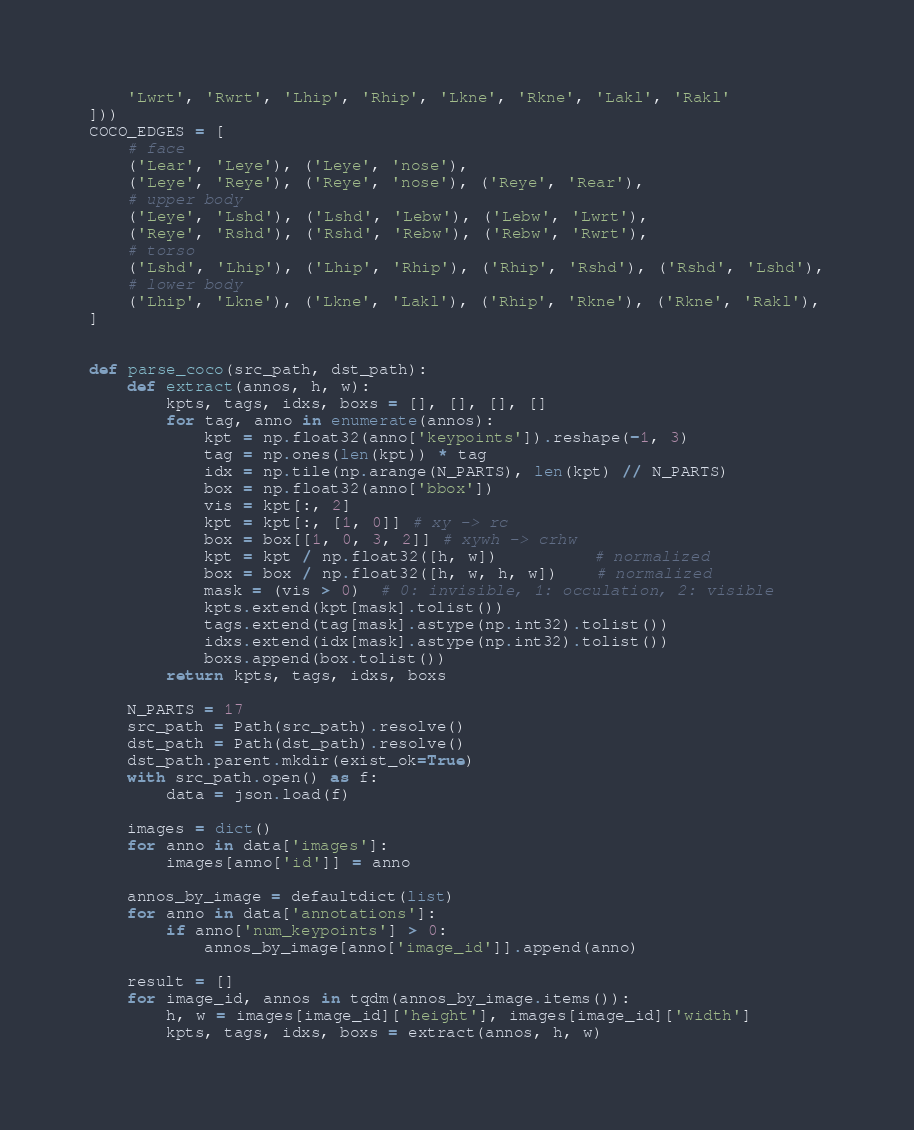Convert code to text. <code><loc_0><loc_0><loc_500><loc_500><_Python_>    'Lwrt', 'Rwrt', 'Lhip', 'Rhip', 'Lkne', 'Rkne', 'Lakl', 'Rakl'
]))
COCO_EDGES = [
    # face
    ('Lear', 'Leye'), ('Leye', 'nose'),
    ('Leye', 'Reye'), ('Reye', 'nose'), ('Reye', 'Rear'),
    # upper body
    ('Leye', 'Lshd'), ('Lshd', 'Lebw'), ('Lebw', 'Lwrt'),
    ('Reye', 'Rshd'), ('Rshd', 'Rebw'), ('Rebw', 'Rwrt'),
    # torso
    ('Lshd', 'Lhip'), ('Lhip', 'Rhip'), ('Rhip', 'Rshd'), ('Rshd', 'Lshd'),
    # lower body
    ('Lhip', 'Lkne'), ('Lkne', 'Lakl'), ('Rhip', 'Rkne'), ('Rkne', 'Rakl'),
]


def parse_coco(src_path, dst_path):
    def extract(annos, h, w):
        kpts, tags, idxs, boxs = [], [], [], []
        for tag, anno in enumerate(annos):
            kpt = np.float32(anno['keypoints']).reshape(-1, 3)
            tag = np.ones(len(kpt)) * tag
            idx = np.tile(np.arange(N_PARTS), len(kpt) // N_PARTS)
            box = np.float32(anno['bbox'])
            vis = kpt[:, 2]
            kpt = kpt[:, [1, 0]] # xy -> rc
            box = box[[1, 0, 3, 2]] # xywh -> crhw
            kpt = kpt / np.float32([h, w])          # normalized
            box = box / np.float32([h, w, h, w])    # normalized
            mask = (vis > 0)  # 0: invisible, 1: occulation, 2: visible
            kpts.extend(kpt[mask].tolist())
            tags.extend(tag[mask].astype(np.int32).tolist())
            idxs.extend(idx[mask].astype(np.int32).tolist())
            boxs.append(box.tolist())
        return kpts, tags, idxs, boxs

    N_PARTS = 17
    src_path = Path(src_path).resolve()
    dst_path = Path(dst_path).resolve()
    dst_path.parent.mkdir(exist_ok=True)
    with src_path.open() as f:
        data = json.load(f)

    images = dict()
    for anno in data['images']:
        images[anno['id']] = anno

    annos_by_image = defaultdict(list)
    for anno in data['annotations']:
        if anno['num_keypoints'] > 0:
            annos_by_image[anno['image_id']].append(anno)

    result = []
    for image_id, annos in tqdm(annos_by_image.items()):
        h, w = images[image_id]['height'], images[image_id]['width']
        kpts, tags, idxs, boxs = extract(annos, h, w)</code> 